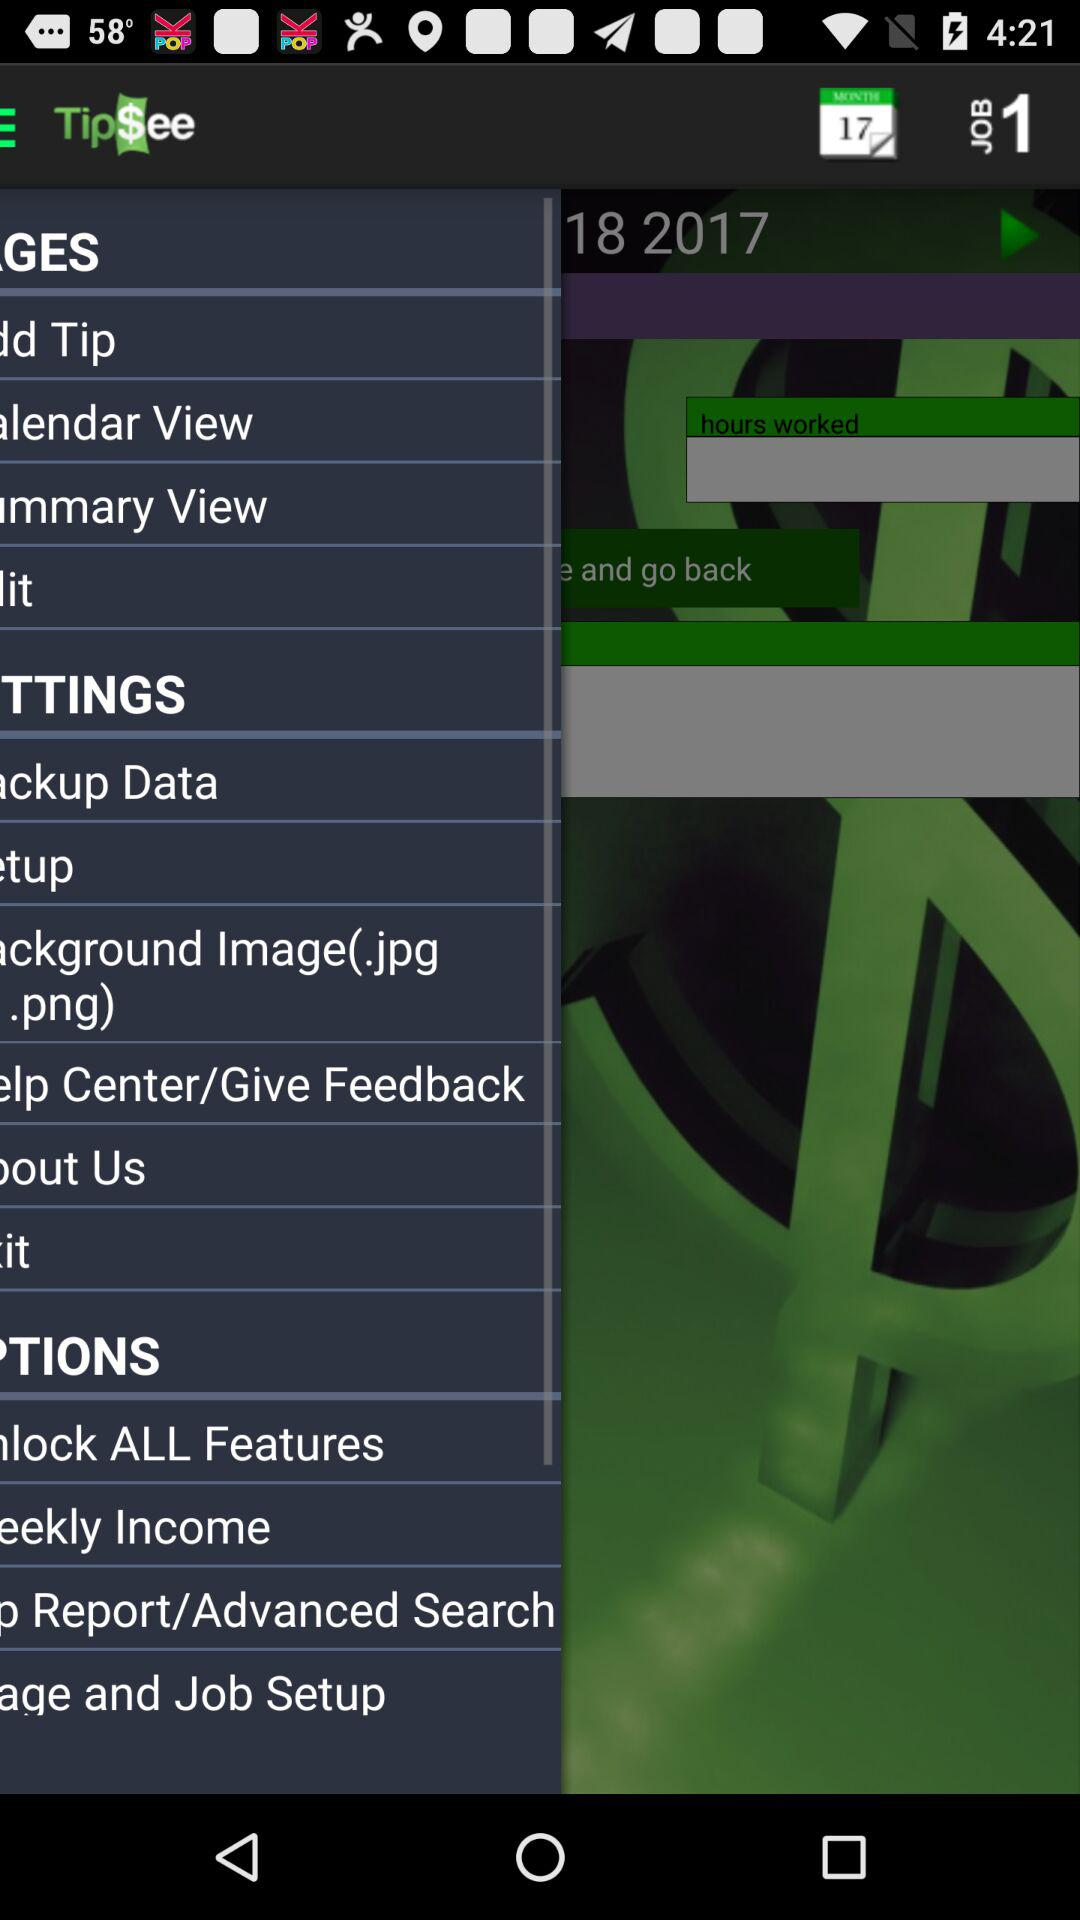What is the application name? The application name is "Tip$ee". 